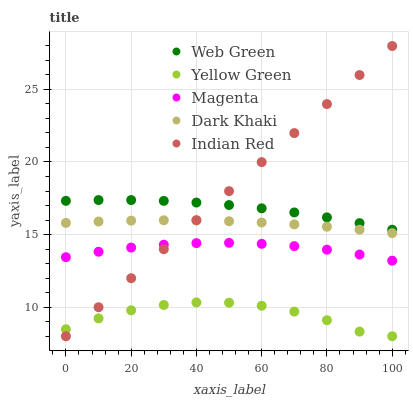Does Yellow Green have the minimum area under the curve?
Answer yes or no. Yes. Does Indian Red have the maximum area under the curve?
Answer yes or no. Yes. Does Magenta have the minimum area under the curve?
Answer yes or no. No. Does Magenta have the maximum area under the curve?
Answer yes or no. No. Is Indian Red the smoothest?
Answer yes or no. Yes. Is Yellow Green the roughest?
Answer yes or no. Yes. Is Magenta the smoothest?
Answer yes or no. No. Is Magenta the roughest?
Answer yes or no. No. Does Indian Red have the lowest value?
Answer yes or no. Yes. Does Magenta have the lowest value?
Answer yes or no. No. Does Indian Red have the highest value?
Answer yes or no. Yes. Does Magenta have the highest value?
Answer yes or no. No. Is Yellow Green less than Magenta?
Answer yes or no. Yes. Is Web Green greater than Yellow Green?
Answer yes or no. Yes. Does Dark Khaki intersect Indian Red?
Answer yes or no. Yes. Is Dark Khaki less than Indian Red?
Answer yes or no. No. Is Dark Khaki greater than Indian Red?
Answer yes or no. No. Does Yellow Green intersect Magenta?
Answer yes or no. No. 